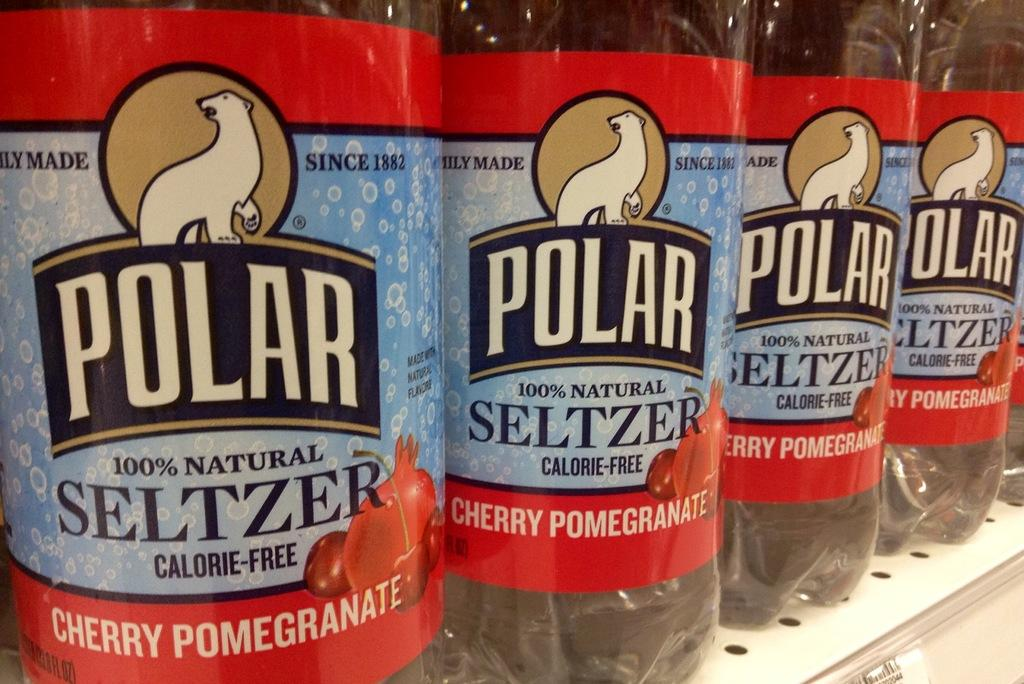<image>
Relay a brief, clear account of the picture shown. A close up of the labels of four identical Polar Cherry Pomegranite flavoured Selzer bottles. 